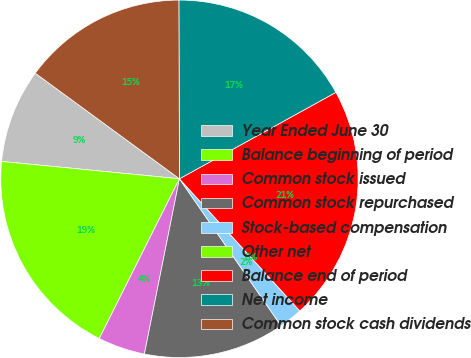Convert chart to OTSL. <chart><loc_0><loc_0><loc_500><loc_500><pie_chart><fcel>Year Ended June 30<fcel>Balance beginning of period<fcel>Common stock issued<fcel>Common stock repurchased<fcel>Stock-based compensation<fcel>Other net<fcel>Balance end of period<fcel>Net income<fcel>Common stock cash dividends<nl><fcel>8.51%<fcel>19.15%<fcel>4.26%<fcel>12.77%<fcel>2.13%<fcel>0.0%<fcel>21.28%<fcel>17.02%<fcel>14.89%<nl></chart> 